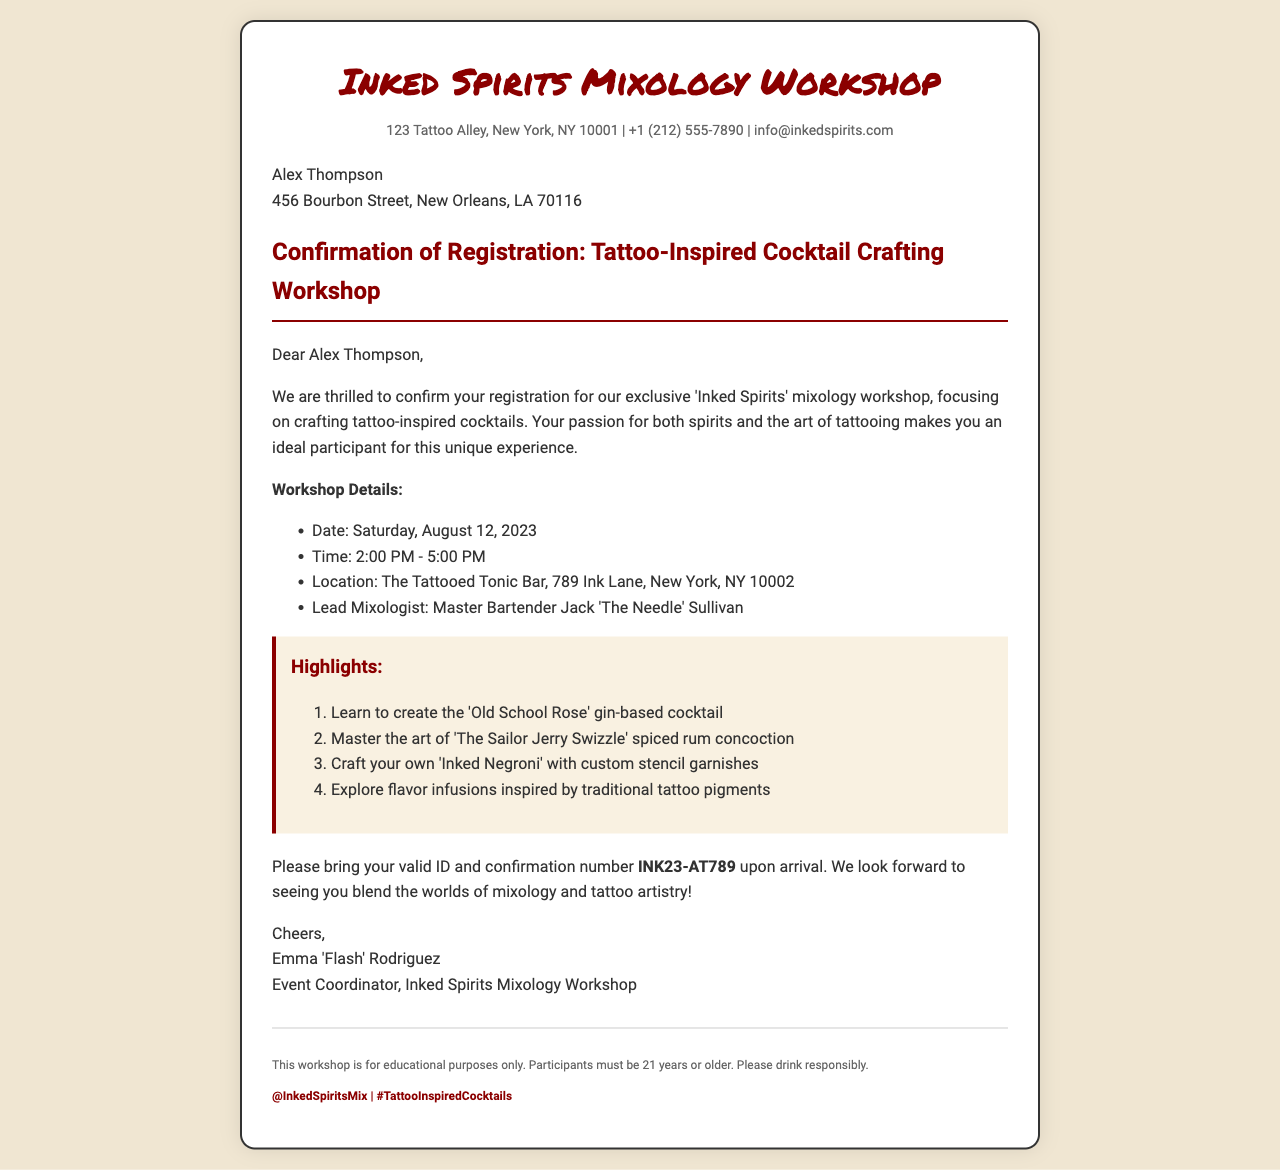What is the name of the workshop? The name of the workshop is stated prominently at the top of the document as "Inked Spirits Mixology Workshop".
Answer: Inked Spirits Mixology Workshop Who is the lead mixologist? The lead mixologist's name is provided in the workshop details listed in the document.
Answer: Master Bartender Jack 'The Needle' Sullivan What is the date of the workshop? The date of the workshop is mentioned in the details section of the document.
Answer: Saturday, August 12, 2023 What is the confirmation number? The confirmation number is specified in the final paragraph of the document for the participant to bring.
Answer: INK23-AT789 What must participants bring upon arrival? This is indicated in the last paragraph of the body section where it highlights what is necessary for entry.
Answer: valid ID and confirmation number How many highlights are listed in the document? The highlights section lists a total of specific cocktail crafting activities, which is a set number.
Answer: Four What should participants be aware of regarding age? This information is included in the footer section regarding participation requirements.
Answer: 21 years or older 